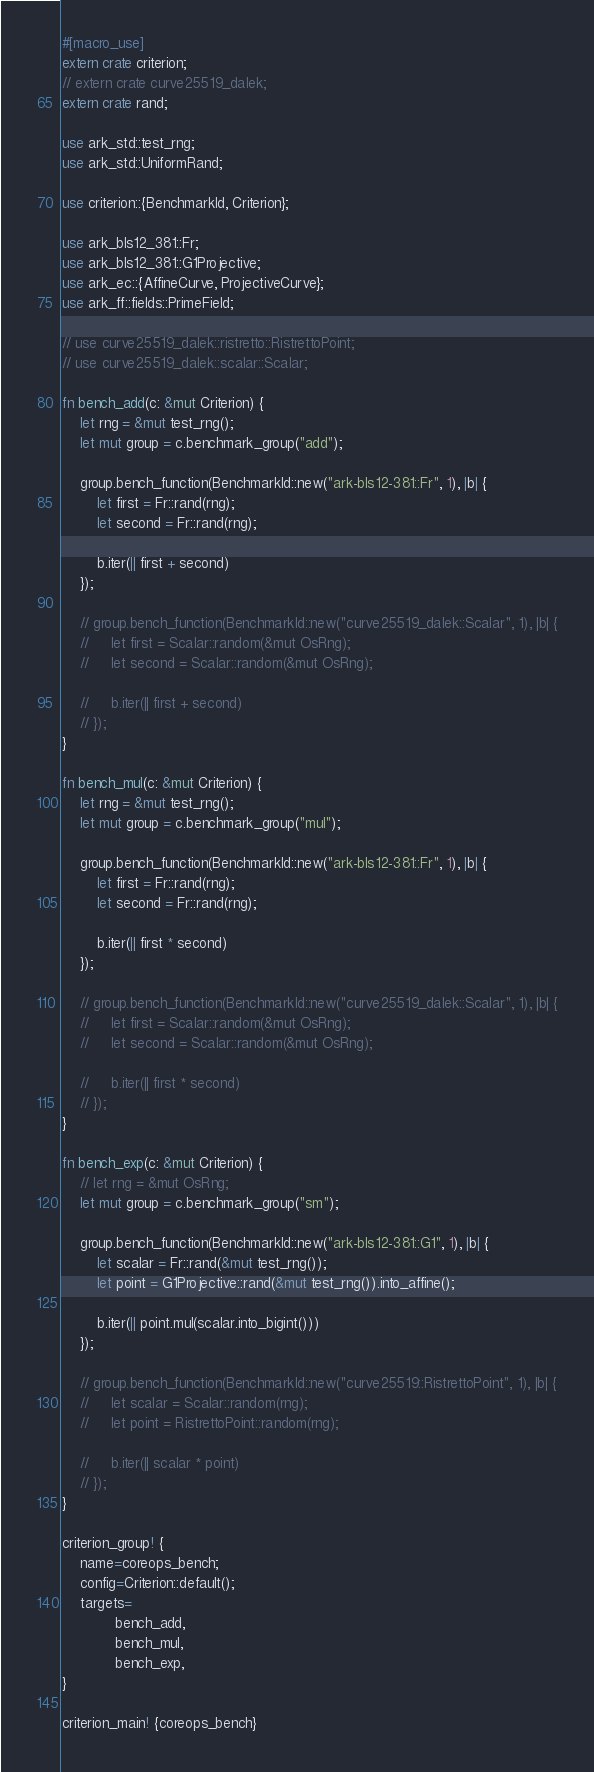Convert code to text. <code><loc_0><loc_0><loc_500><loc_500><_Rust_>#[macro_use]
extern crate criterion;
// extern crate curve25519_dalek;
extern crate rand;

use ark_std::test_rng;
use ark_std::UniformRand;

use criterion::{BenchmarkId, Criterion};

use ark_bls12_381::Fr;
use ark_bls12_381::G1Projective;
use ark_ec::{AffineCurve, ProjectiveCurve};
use ark_ff::fields::PrimeField;

// use curve25519_dalek::ristretto::RistrettoPoint;
// use curve25519_dalek::scalar::Scalar;

fn bench_add(c: &mut Criterion) {
    let rng = &mut test_rng();
    let mut group = c.benchmark_group("add");

    group.bench_function(BenchmarkId::new("ark-bls12-381::Fr", 1), |b| {
        let first = Fr::rand(rng);
        let second = Fr::rand(rng);

        b.iter(|| first + second)
    });

    // group.bench_function(BenchmarkId::new("curve25519_dalek::Scalar", 1), |b| {
    //     let first = Scalar::random(&mut OsRng);
    //     let second = Scalar::random(&mut OsRng);

    //     b.iter(|| first + second)
    // });
}

fn bench_mul(c: &mut Criterion) {
    let rng = &mut test_rng();
    let mut group = c.benchmark_group("mul");

    group.bench_function(BenchmarkId::new("ark-bls12-381::Fr", 1), |b| {
        let first = Fr::rand(rng);
        let second = Fr::rand(rng);

        b.iter(|| first * second)
    });

    // group.bench_function(BenchmarkId::new("curve25519_dalek::Scalar", 1), |b| {
    //     let first = Scalar::random(&mut OsRng);
    //     let second = Scalar::random(&mut OsRng);

    //     b.iter(|| first * second)
    // });
}

fn bench_exp(c: &mut Criterion) {
    // let rng = &mut OsRng;
    let mut group = c.benchmark_group("sm");

    group.bench_function(BenchmarkId::new("ark-bls12-381::G1", 1), |b| {
        let scalar = Fr::rand(&mut test_rng());
        let point = G1Projective::rand(&mut test_rng()).into_affine();

        b.iter(|| point.mul(scalar.into_bigint()))
    });

    // group.bench_function(BenchmarkId::new("curve25519::RistrettoPoint", 1), |b| {
    //     let scalar = Scalar::random(rng);
    //     let point = RistrettoPoint::random(rng);

    //     b.iter(|| scalar * point)
    // });
}

criterion_group! {
    name=coreops_bench;
    config=Criterion::default();
    targets=
            bench_add,
            bench_mul,
            bench_exp,
}

criterion_main! {coreops_bench}
</code> 